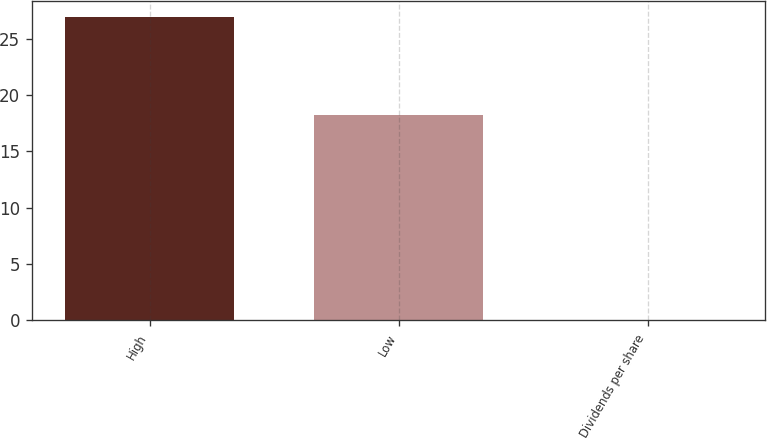Convert chart to OTSL. <chart><loc_0><loc_0><loc_500><loc_500><bar_chart><fcel>High<fcel>Low<fcel>Dividends per share<nl><fcel>26.98<fcel>18.26<fcel>0.06<nl></chart> 